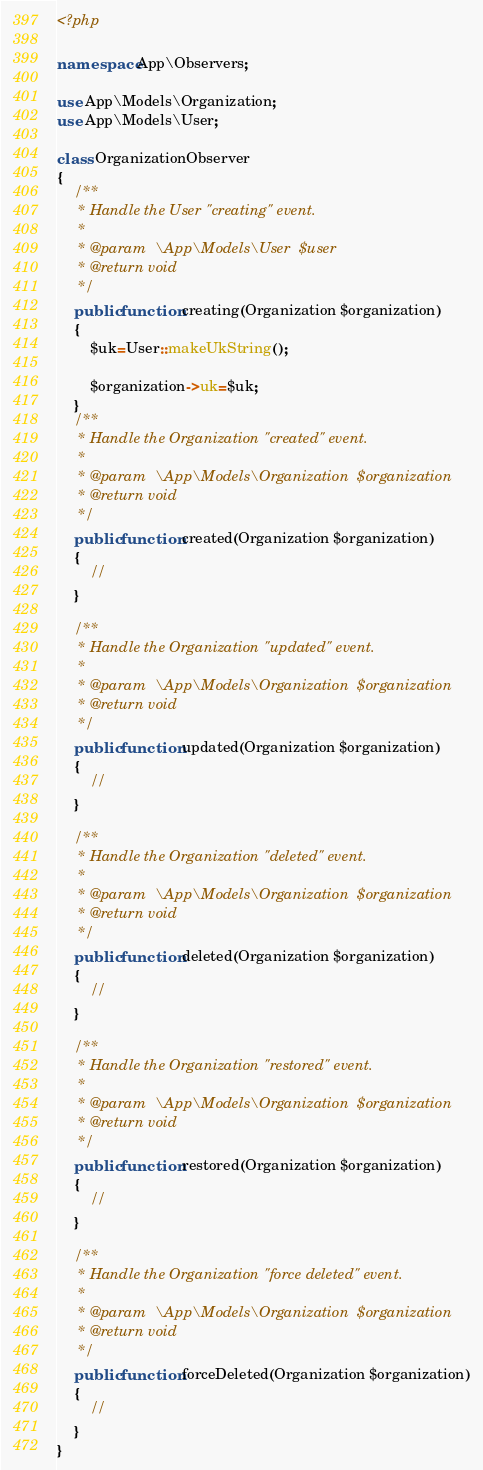<code> <loc_0><loc_0><loc_500><loc_500><_PHP_><?php

namespace App\Observers;

use App\Models\Organization;
use App\Models\User;

class OrganizationObserver
{
    /**
     * Handle the User "creating" event.
     *
     * @param  \App\Models\User  $user
     * @return void
     */
    public function creating(Organization $organization)
    {
        $uk=User::makeUkString();

        $organization->uk=$uk;
    }
    /**
     * Handle the Organization "created" event.
     *
     * @param  \App\Models\Organization  $organization
     * @return void
     */
    public function created(Organization $organization)
    {
        //
    }

    /**
     * Handle the Organization "updated" event.
     *
     * @param  \App\Models\Organization  $organization
     * @return void
     */
    public function updated(Organization $organization)
    {
        //
    }

    /**
     * Handle the Organization "deleted" event.
     *
     * @param  \App\Models\Organization  $organization
     * @return void
     */
    public function deleted(Organization $organization)
    {
        //
    }

    /**
     * Handle the Organization "restored" event.
     *
     * @param  \App\Models\Organization  $organization
     * @return void
     */
    public function restored(Organization $organization)
    {
        //
    }

    /**
     * Handle the Organization "force deleted" event.
     *
     * @param  \App\Models\Organization  $organization
     * @return void
     */
    public function forceDeleted(Organization $organization)
    {
        //
    }
}
</code> 